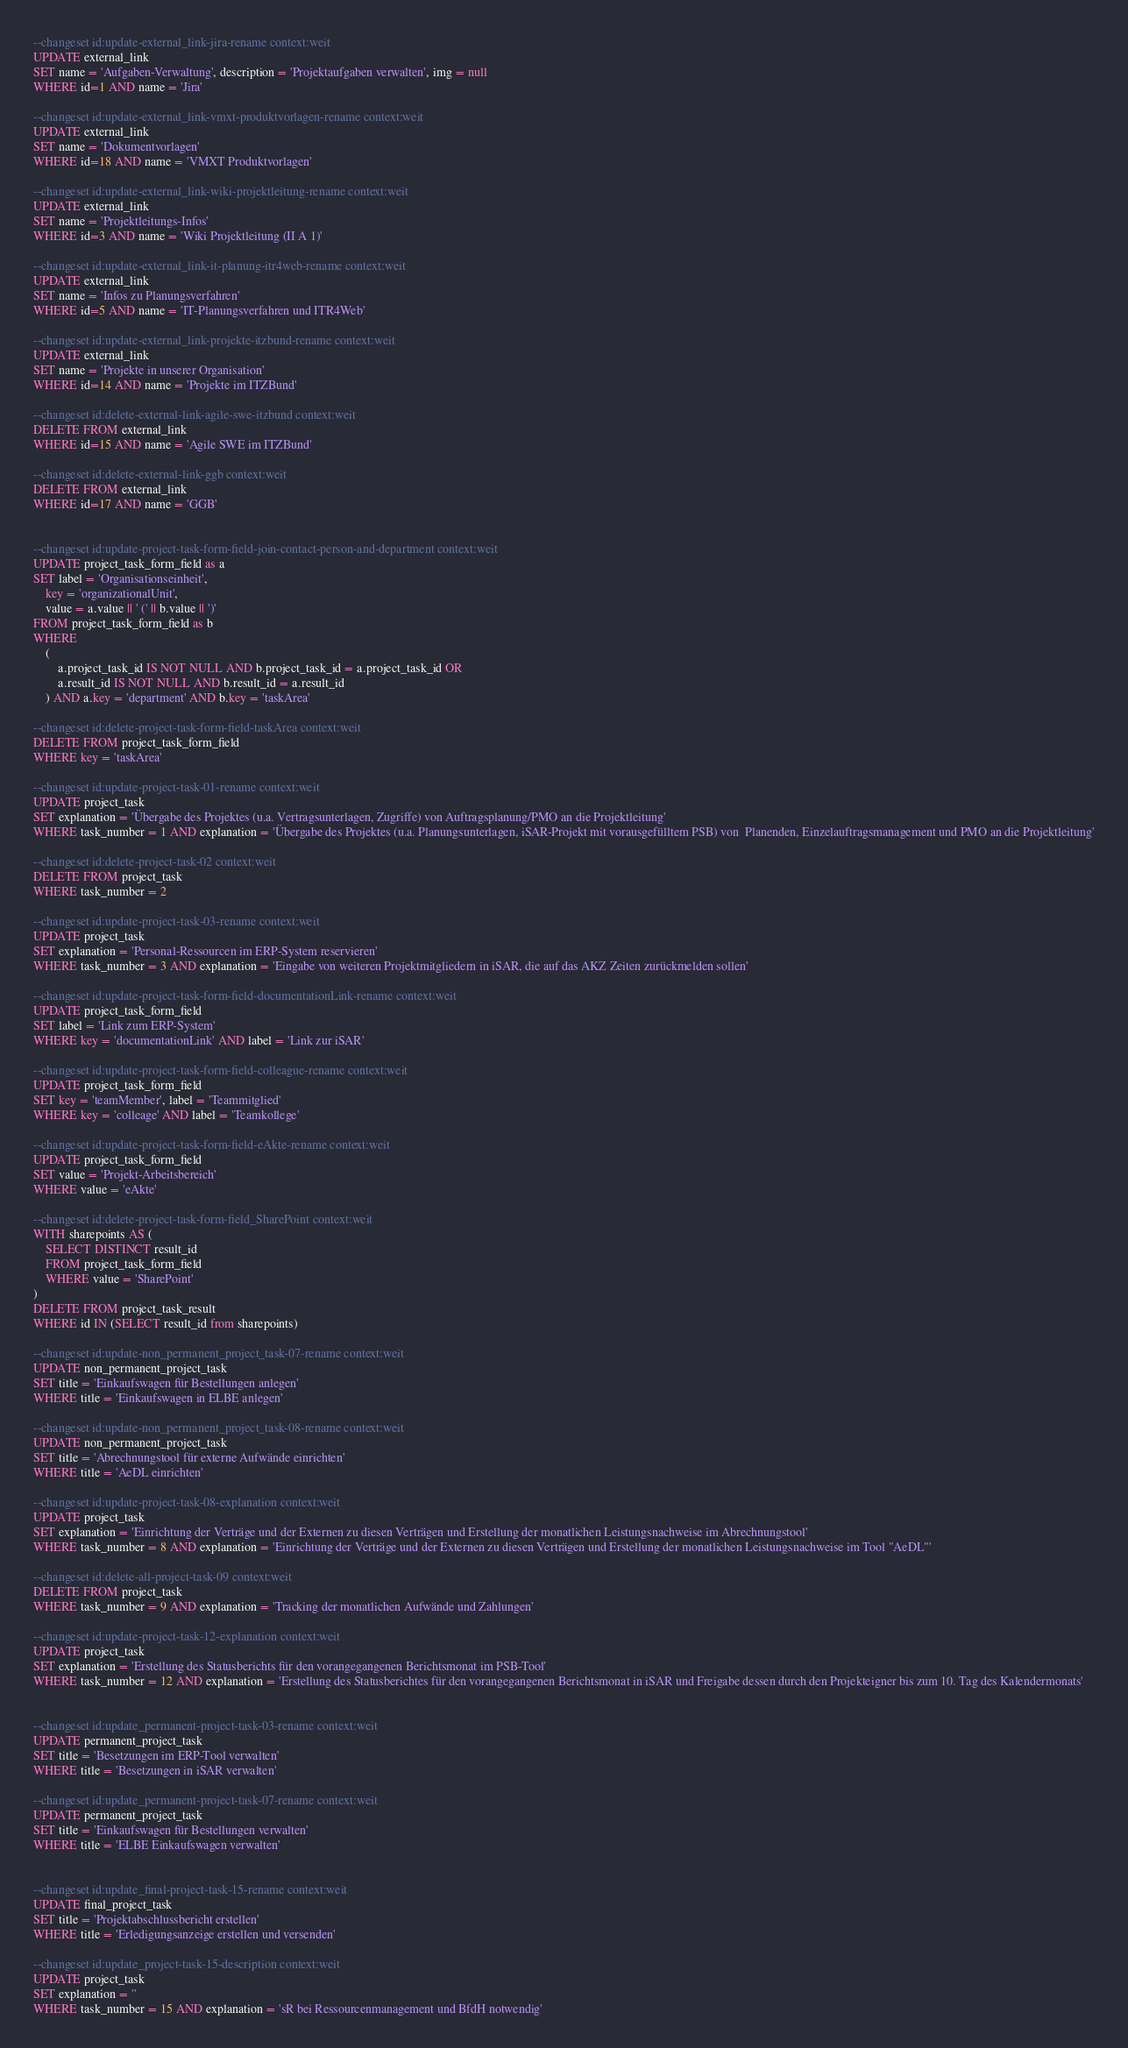<code> <loc_0><loc_0><loc_500><loc_500><_SQL_>
--changeset id:update-external_link-jira-rename context:weit
UPDATE external_link
SET name = 'Aufgaben-Verwaltung', description = 'Projektaufgaben verwalten', img = null
WHERE id=1 AND name = 'Jira'

--changeset id:update-external_link-vmxt-produktvorlagen-rename context:weit
UPDATE external_link
SET name = 'Dokumentvorlagen'
WHERE id=18 AND name = 'VMXT Produktvorlagen'

--changeset id:update-external_link-wiki-projektleitung-rename context:weit
UPDATE external_link
SET name = 'Projektleitungs-Infos'
WHERE id=3 AND name = 'Wiki Projektleitung (II A 1)'

--changeset id:update-external_link-it-planung-itr4web-rename context:weit
UPDATE external_link
SET name = 'Infos zu Planungsverfahren'
WHERE id=5 AND name = 'IT-Planungsverfahren und ITR4Web'

--changeset id:update-external_link-projekte-itzbund-rename context:weit
UPDATE external_link
SET name = 'Projekte in unserer Organisation'
WHERE id=14 AND name = 'Projekte im ITZBund'

--changeset id:delete-external-link-agile-swe-itzbund context:weit
DELETE FROM external_link
WHERE id=15 AND name = 'Agile SWE im ITZBund'

--changeset id:delete-external-link-ggb context:weit
DELETE FROM external_link
WHERE id=17 AND name = 'GGB'


--changeset id:update-project-task-form-field-join-contact-person-and-department context:weit
UPDATE project_task_form_field as a
SET label = 'Organisationseinheit',
    key = 'organizationalUnit',
    value = a.value || ' (' || b.value || ')'
FROM project_task_form_field as b
WHERE
    (
        a.project_task_id IS NOT NULL AND b.project_task_id = a.project_task_id OR
        a.result_id IS NOT NULL AND b.result_id = a.result_id
    ) AND a.key = 'department' AND b.key = 'taskArea'

--changeset id:delete-project-task-form-field-taskArea context:weit
DELETE FROM project_task_form_field
WHERE key = 'taskArea'

--changeset id:update-project-task-01-rename context:weit
UPDATE project_task
SET explanation = 'Übergabe des Projektes (u.a. Vertragsunterlagen, Zugriffe) von Auftragsplanung/PMO an die Projektleitung'
WHERE task_number = 1 AND explanation = 'Übergabe des Projektes (u.a. Planungsunterlagen, iSAR-Projekt mit vorausgefülltem PSB) von  Planenden, Einzelauftragsmanagement und PMO an die Projektleitung'

--changeset id:delete-project-task-02 context:weit
DELETE FROM project_task
WHERE task_number = 2

--changeset id:update-project-task-03-rename context:weit
UPDATE project_task
SET explanation = 'Personal-Ressourcen im ERP-System reservieren'
WHERE task_number = 3 AND explanation = 'Eingabe von weiteren Projektmitgliedern in iSAR, die auf das AKZ Zeiten zurückmelden sollen'

--changeset id:update-project-task-form-field-documentationLink-rename context:weit
UPDATE project_task_form_field
SET label = 'Link zum ERP-System'
WHERE key = 'documentationLink' AND label = 'Link zur iSAR'

--changeset id:update-project-task-form-field-colleague-rename context:weit
UPDATE project_task_form_field
SET key = 'teamMember', label = 'Teammitglied'
WHERE key = 'colleage' AND label = 'Teamkollege'

--changeset id:update-project-task-form-field-eAkte-rename context:weit
UPDATE project_task_form_field
SET value = 'Projekt-Arbeitsbereich'
WHERE value = 'eAkte'

--changeset id:delete-project-task-form-field_SharePoint context:weit
WITH sharepoints AS (
    SELECT DISTINCT result_id
    FROM project_task_form_field
    WHERE value = 'SharePoint'
)
DELETE FROM project_task_result
WHERE id IN (SELECT result_id from sharepoints)

--changeset id:update-non_permanent_project_task-07-rename context:weit
UPDATE non_permanent_project_task
SET title = 'Einkaufswagen für Bestellungen anlegen'
WHERE title = 'Einkaufswagen in ELBE anlegen'

--changeset id:update-non_permanent_project_task-08-rename context:weit
UPDATE non_permanent_project_task
SET title = 'Abrechnungstool für externe Aufwände einrichten'
WHERE title = 'AeDL einrichten'

--changeset id:update-project-task-08-explanation context:weit
UPDATE project_task
SET explanation = 'Einrichtung der Verträge und der Externen zu diesen Verträgen und Erstellung der monatlichen Leistungsnachweise im Abrechnungstool'
WHERE task_number = 8 AND explanation = 'Einrichtung der Verträge und der Externen zu diesen Verträgen und Erstellung der monatlichen Leistungsnachweise im Tool "AeDL"'

--changeset id:delete-all-project-task-09 context:weit
DELETE FROM project_task
WHERE task_number = 9 AND explanation = 'Tracking der monatlichen Aufwände und Zahlungen'

--changeset id:update-project-task-12-explanation context:weit
UPDATE project_task
SET explanation = 'Erstellung des Statusberichts für den vorangegangenen Berichtsmonat im PSB-Tool'
WHERE task_number = 12 AND explanation = 'Erstellung des Statusberichtes für den vorangegangenen Berichtsmonat in iSAR und Freigabe dessen durch den Projekteigner bis zum 10. Tag des Kalendermonats'


--changeset id:update_permanent-project-task-03-rename context:weit
UPDATE permanent_project_task
SET title = 'Besetzungen im ERP-Tool verwalten'
WHERE title = 'Besetzungen in iSAR verwalten'

--changeset id:update_permanent-project-task-07-rename context:weit
UPDATE permanent_project_task
SET title = 'Einkaufswagen für Bestellungen verwalten'
WHERE title = 'ELBE Einkaufswagen verwalten'


--changeset id:update_final-project-task-15-rename context:weit
UPDATE final_project_task
SET title = 'Projektabschlussbericht erstellen'
WHERE title = 'Erledigungsanzeige erstellen und versenden'

--changeset id:update_project-task-15-description context:weit
UPDATE project_task
SET explanation = ''
WHERE task_number = 15 AND explanation = 'sR bei Ressourcenmanagement und BfdH notwendig'
</code> 